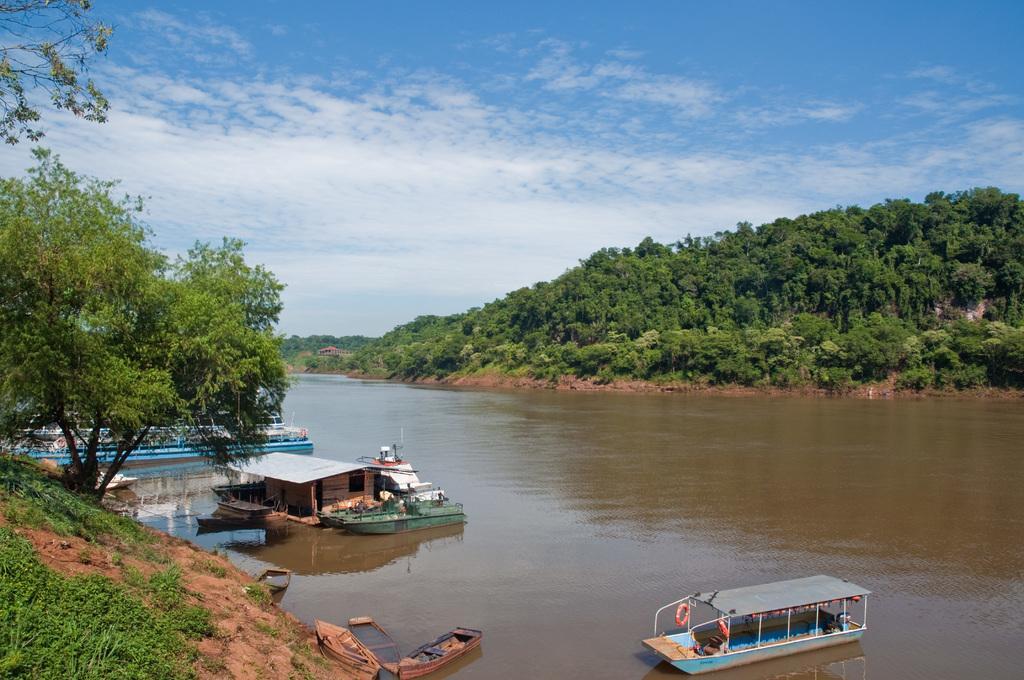Could you give a brief overview of what you see in this image? In this image there is a river with some boats beside that there are mountains with trees and clouds in the sky. 